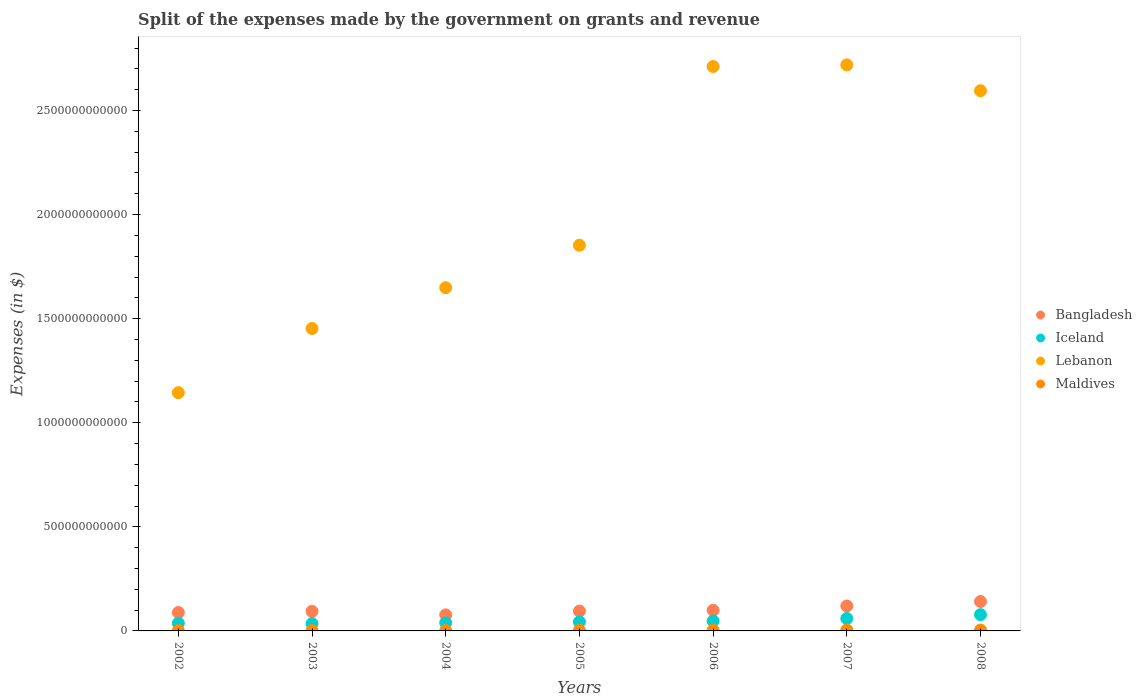How many different coloured dotlines are there?
Offer a very short reply. 4. What is the expenses made by the government on grants and revenue in Maldives in 2003?
Your answer should be compact. 1.79e+09. Across all years, what is the maximum expenses made by the government on grants and revenue in Bangladesh?
Give a very brief answer. 1.41e+11. Across all years, what is the minimum expenses made by the government on grants and revenue in Iceland?
Provide a succinct answer. 3.50e+1. In which year was the expenses made by the government on grants and revenue in Bangladesh maximum?
Provide a succinct answer. 2008. What is the total expenses made by the government on grants and revenue in Bangladesh in the graph?
Your response must be concise. 7.15e+11. What is the difference between the expenses made by the government on grants and revenue in Lebanon in 2003 and that in 2007?
Keep it short and to the point. -1.27e+12. What is the difference between the expenses made by the government on grants and revenue in Iceland in 2002 and the expenses made by the government on grants and revenue in Bangladesh in 2003?
Make the answer very short. -5.69e+1. What is the average expenses made by the government on grants and revenue in Iceland per year?
Keep it short and to the point. 4.86e+1. In the year 2008, what is the difference between the expenses made by the government on grants and revenue in Lebanon and expenses made by the government on grants and revenue in Bangladesh?
Your answer should be compact. 2.45e+12. What is the ratio of the expenses made by the government on grants and revenue in Maldives in 2003 to that in 2007?
Ensure brevity in your answer.  0.39. Is the expenses made by the government on grants and revenue in Iceland in 2002 less than that in 2007?
Your answer should be very brief. Yes. Is the difference between the expenses made by the government on grants and revenue in Lebanon in 2005 and 2006 greater than the difference between the expenses made by the government on grants and revenue in Bangladesh in 2005 and 2006?
Offer a terse response. No. What is the difference between the highest and the second highest expenses made by the government on grants and revenue in Lebanon?
Make the answer very short. 8.00e+09. What is the difference between the highest and the lowest expenses made by the government on grants and revenue in Bangladesh?
Your response must be concise. 6.40e+1. Is it the case that in every year, the sum of the expenses made by the government on grants and revenue in Bangladesh and expenses made by the government on grants and revenue in Iceland  is greater than the sum of expenses made by the government on grants and revenue in Maldives and expenses made by the government on grants and revenue in Lebanon?
Provide a short and direct response. No. Is it the case that in every year, the sum of the expenses made by the government on grants and revenue in Lebanon and expenses made by the government on grants and revenue in Bangladesh  is greater than the expenses made by the government on grants and revenue in Maldives?
Your response must be concise. Yes. Does the expenses made by the government on grants and revenue in Lebanon monotonically increase over the years?
Offer a very short reply. No. Is the expenses made by the government on grants and revenue in Bangladesh strictly greater than the expenses made by the government on grants and revenue in Iceland over the years?
Provide a short and direct response. Yes. How many dotlines are there?
Give a very brief answer. 4. How many years are there in the graph?
Make the answer very short. 7. What is the difference between two consecutive major ticks on the Y-axis?
Provide a short and direct response. 5.00e+11. Are the values on the major ticks of Y-axis written in scientific E-notation?
Keep it short and to the point. No. Does the graph contain any zero values?
Offer a terse response. No. How many legend labels are there?
Your response must be concise. 4. What is the title of the graph?
Ensure brevity in your answer.  Split of the expenses made by the government on grants and revenue. Does "Paraguay" appear as one of the legend labels in the graph?
Your response must be concise. No. What is the label or title of the Y-axis?
Provide a succinct answer. Expenses (in $). What is the Expenses (in $) in Bangladesh in 2002?
Provide a succinct answer. 8.84e+1. What is the Expenses (in $) of Iceland in 2002?
Provide a succinct answer. 3.72e+1. What is the Expenses (in $) in Lebanon in 2002?
Ensure brevity in your answer.  1.14e+12. What is the Expenses (in $) of Maldives in 2002?
Your answer should be very brief. 1.62e+09. What is the Expenses (in $) in Bangladesh in 2003?
Provide a short and direct response. 9.41e+1. What is the Expenses (in $) of Iceland in 2003?
Provide a succinct answer. 3.50e+1. What is the Expenses (in $) of Lebanon in 2003?
Ensure brevity in your answer.  1.45e+12. What is the Expenses (in $) of Maldives in 2003?
Ensure brevity in your answer.  1.79e+09. What is the Expenses (in $) in Bangladesh in 2004?
Give a very brief answer. 7.72e+1. What is the Expenses (in $) in Iceland in 2004?
Keep it short and to the point. 3.89e+1. What is the Expenses (in $) in Lebanon in 2004?
Provide a succinct answer. 1.65e+12. What is the Expenses (in $) of Maldives in 2004?
Give a very brief answer. 1.76e+09. What is the Expenses (in $) in Bangladesh in 2005?
Provide a short and direct response. 9.52e+1. What is the Expenses (in $) of Iceland in 2005?
Provide a succinct answer. 4.34e+1. What is the Expenses (in $) of Lebanon in 2005?
Offer a very short reply. 1.85e+12. What is the Expenses (in $) in Maldives in 2005?
Ensure brevity in your answer.  2.86e+09. What is the Expenses (in $) of Bangladesh in 2006?
Offer a terse response. 9.91e+1. What is the Expenses (in $) of Iceland in 2006?
Offer a very short reply. 4.77e+1. What is the Expenses (in $) in Lebanon in 2006?
Your answer should be compact. 2.71e+12. What is the Expenses (in $) of Maldives in 2006?
Offer a very short reply. 3.73e+09. What is the Expenses (in $) of Bangladesh in 2007?
Offer a terse response. 1.20e+11. What is the Expenses (in $) in Iceland in 2007?
Offer a terse response. 5.97e+1. What is the Expenses (in $) of Lebanon in 2007?
Your response must be concise. 2.72e+12. What is the Expenses (in $) of Maldives in 2007?
Your answer should be very brief. 4.63e+09. What is the Expenses (in $) in Bangladesh in 2008?
Ensure brevity in your answer.  1.41e+11. What is the Expenses (in $) of Iceland in 2008?
Offer a very short reply. 7.80e+1. What is the Expenses (in $) of Lebanon in 2008?
Keep it short and to the point. 2.59e+12. What is the Expenses (in $) in Maldives in 2008?
Keep it short and to the point. 4.05e+09. Across all years, what is the maximum Expenses (in $) of Bangladesh?
Ensure brevity in your answer.  1.41e+11. Across all years, what is the maximum Expenses (in $) in Iceland?
Offer a terse response. 7.80e+1. Across all years, what is the maximum Expenses (in $) in Lebanon?
Your answer should be compact. 2.72e+12. Across all years, what is the maximum Expenses (in $) of Maldives?
Provide a short and direct response. 4.63e+09. Across all years, what is the minimum Expenses (in $) in Bangladesh?
Offer a very short reply. 7.72e+1. Across all years, what is the minimum Expenses (in $) in Iceland?
Your answer should be very brief. 3.50e+1. Across all years, what is the minimum Expenses (in $) of Lebanon?
Provide a short and direct response. 1.14e+12. Across all years, what is the minimum Expenses (in $) in Maldives?
Your answer should be very brief. 1.62e+09. What is the total Expenses (in $) in Bangladesh in the graph?
Offer a terse response. 7.15e+11. What is the total Expenses (in $) in Iceland in the graph?
Your answer should be compact. 3.40e+11. What is the total Expenses (in $) in Lebanon in the graph?
Your answer should be compact. 1.41e+13. What is the total Expenses (in $) in Maldives in the graph?
Ensure brevity in your answer.  2.04e+1. What is the difference between the Expenses (in $) of Bangladesh in 2002 and that in 2003?
Your response must be concise. -5.69e+09. What is the difference between the Expenses (in $) in Iceland in 2002 and that in 2003?
Offer a very short reply. 2.13e+09. What is the difference between the Expenses (in $) of Lebanon in 2002 and that in 2003?
Offer a very short reply. -3.08e+11. What is the difference between the Expenses (in $) in Maldives in 2002 and that in 2003?
Ensure brevity in your answer.  -1.73e+08. What is the difference between the Expenses (in $) in Bangladesh in 2002 and that in 2004?
Offer a very short reply. 1.12e+1. What is the difference between the Expenses (in $) in Iceland in 2002 and that in 2004?
Provide a succinct answer. -1.70e+09. What is the difference between the Expenses (in $) of Lebanon in 2002 and that in 2004?
Make the answer very short. -5.04e+11. What is the difference between the Expenses (in $) in Maldives in 2002 and that in 2004?
Keep it short and to the point. -1.38e+08. What is the difference between the Expenses (in $) of Bangladesh in 2002 and that in 2005?
Offer a very short reply. -6.87e+09. What is the difference between the Expenses (in $) of Iceland in 2002 and that in 2005?
Your answer should be compact. -6.27e+09. What is the difference between the Expenses (in $) of Lebanon in 2002 and that in 2005?
Your answer should be very brief. -7.08e+11. What is the difference between the Expenses (in $) in Maldives in 2002 and that in 2005?
Ensure brevity in your answer.  -1.24e+09. What is the difference between the Expenses (in $) in Bangladesh in 2002 and that in 2006?
Your answer should be compact. -1.07e+1. What is the difference between the Expenses (in $) in Iceland in 2002 and that in 2006?
Keep it short and to the point. -1.06e+1. What is the difference between the Expenses (in $) in Lebanon in 2002 and that in 2006?
Provide a short and direct response. -1.57e+12. What is the difference between the Expenses (in $) in Maldives in 2002 and that in 2006?
Offer a terse response. -2.12e+09. What is the difference between the Expenses (in $) of Bangladesh in 2002 and that in 2007?
Ensure brevity in your answer.  -3.15e+1. What is the difference between the Expenses (in $) in Iceland in 2002 and that in 2007?
Your response must be concise. -2.25e+1. What is the difference between the Expenses (in $) of Lebanon in 2002 and that in 2007?
Give a very brief answer. -1.57e+12. What is the difference between the Expenses (in $) in Maldives in 2002 and that in 2007?
Keep it short and to the point. -3.01e+09. What is the difference between the Expenses (in $) in Bangladesh in 2002 and that in 2008?
Your answer should be compact. -5.28e+1. What is the difference between the Expenses (in $) of Iceland in 2002 and that in 2008?
Give a very brief answer. -4.09e+1. What is the difference between the Expenses (in $) in Lebanon in 2002 and that in 2008?
Your answer should be very brief. -1.45e+12. What is the difference between the Expenses (in $) in Maldives in 2002 and that in 2008?
Make the answer very short. -2.43e+09. What is the difference between the Expenses (in $) in Bangladesh in 2003 and that in 2004?
Your answer should be compact. 1.69e+1. What is the difference between the Expenses (in $) in Iceland in 2003 and that in 2004?
Give a very brief answer. -3.83e+09. What is the difference between the Expenses (in $) of Lebanon in 2003 and that in 2004?
Offer a very short reply. -1.96e+11. What is the difference between the Expenses (in $) in Maldives in 2003 and that in 2004?
Ensure brevity in your answer.  3.49e+07. What is the difference between the Expenses (in $) in Bangladesh in 2003 and that in 2005?
Your response must be concise. -1.18e+09. What is the difference between the Expenses (in $) of Iceland in 2003 and that in 2005?
Offer a very short reply. -8.40e+09. What is the difference between the Expenses (in $) of Lebanon in 2003 and that in 2005?
Provide a short and direct response. -4.00e+11. What is the difference between the Expenses (in $) of Maldives in 2003 and that in 2005?
Your answer should be very brief. -1.06e+09. What is the difference between the Expenses (in $) in Bangladesh in 2003 and that in 2006?
Your answer should be very brief. -4.99e+09. What is the difference between the Expenses (in $) of Iceland in 2003 and that in 2006?
Keep it short and to the point. -1.27e+1. What is the difference between the Expenses (in $) in Lebanon in 2003 and that in 2006?
Your answer should be compact. -1.26e+12. What is the difference between the Expenses (in $) in Maldives in 2003 and that in 2006?
Your response must be concise. -1.94e+09. What is the difference between the Expenses (in $) of Bangladesh in 2003 and that in 2007?
Offer a terse response. -2.58e+1. What is the difference between the Expenses (in $) of Iceland in 2003 and that in 2007?
Provide a succinct answer. -2.47e+1. What is the difference between the Expenses (in $) of Lebanon in 2003 and that in 2007?
Your answer should be very brief. -1.27e+12. What is the difference between the Expenses (in $) in Maldives in 2003 and that in 2007?
Your answer should be compact. -2.84e+09. What is the difference between the Expenses (in $) in Bangladesh in 2003 and that in 2008?
Ensure brevity in your answer.  -4.71e+1. What is the difference between the Expenses (in $) in Iceland in 2003 and that in 2008?
Provide a succinct answer. -4.30e+1. What is the difference between the Expenses (in $) in Lebanon in 2003 and that in 2008?
Give a very brief answer. -1.14e+12. What is the difference between the Expenses (in $) in Maldives in 2003 and that in 2008?
Provide a short and direct response. -2.26e+09. What is the difference between the Expenses (in $) of Bangladesh in 2004 and that in 2005?
Offer a terse response. -1.80e+1. What is the difference between the Expenses (in $) of Iceland in 2004 and that in 2005?
Provide a succinct answer. -4.57e+09. What is the difference between the Expenses (in $) in Lebanon in 2004 and that in 2005?
Offer a very short reply. -2.04e+11. What is the difference between the Expenses (in $) of Maldives in 2004 and that in 2005?
Make the answer very short. -1.10e+09. What is the difference between the Expenses (in $) in Bangladesh in 2004 and that in 2006?
Keep it short and to the point. -2.18e+1. What is the difference between the Expenses (in $) of Iceland in 2004 and that in 2006?
Keep it short and to the point. -8.86e+09. What is the difference between the Expenses (in $) of Lebanon in 2004 and that in 2006?
Offer a terse response. -1.06e+12. What is the difference between the Expenses (in $) of Maldives in 2004 and that in 2006?
Provide a succinct answer. -1.98e+09. What is the difference between the Expenses (in $) in Bangladesh in 2004 and that in 2007?
Provide a succinct answer. -4.27e+1. What is the difference between the Expenses (in $) in Iceland in 2004 and that in 2007?
Make the answer very short. -2.08e+1. What is the difference between the Expenses (in $) of Lebanon in 2004 and that in 2007?
Your response must be concise. -1.07e+12. What is the difference between the Expenses (in $) in Maldives in 2004 and that in 2007?
Give a very brief answer. -2.87e+09. What is the difference between the Expenses (in $) in Bangladesh in 2004 and that in 2008?
Give a very brief answer. -6.40e+1. What is the difference between the Expenses (in $) of Iceland in 2004 and that in 2008?
Provide a succinct answer. -3.92e+1. What is the difference between the Expenses (in $) in Lebanon in 2004 and that in 2008?
Keep it short and to the point. -9.46e+11. What is the difference between the Expenses (in $) in Maldives in 2004 and that in 2008?
Ensure brevity in your answer.  -2.29e+09. What is the difference between the Expenses (in $) in Bangladesh in 2005 and that in 2006?
Make the answer very short. -3.81e+09. What is the difference between the Expenses (in $) of Iceland in 2005 and that in 2006?
Offer a very short reply. -4.29e+09. What is the difference between the Expenses (in $) of Lebanon in 2005 and that in 2006?
Offer a very short reply. -8.58e+11. What is the difference between the Expenses (in $) in Maldives in 2005 and that in 2006?
Provide a succinct answer. -8.79e+08. What is the difference between the Expenses (in $) in Bangladesh in 2005 and that in 2007?
Give a very brief answer. -2.46e+1. What is the difference between the Expenses (in $) of Iceland in 2005 and that in 2007?
Ensure brevity in your answer.  -1.63e+1. What is the difference between the Expenses (in $) of Lebanon in 2005 and that in 2007?
Your answer should be very brief. -8.66e+11. What is the difference between the Expenses (in $) in Maldives in 2005 and that in 2007?
Offer a terse response. -1.77e+09. What is the difference between the Expenses (in $) of Bangladesh in 2005 and that in 2008?
Keep it short and to the point. -4.59e+1. What is the difference between the Expenses (in $) in Iceland in 2005 and that in 2008?
Your answer should be compact. -3.46e+1. What is the difference between the Expenses (in $) of Lebanon in 2005 and that in 2008?
Offer a very short reply. -7.42e+11. What is the difference between the Expenses (in $) in Maldives in 2005 and that in 2008?
Make the answer very short. -1.19e+09. What is the difference between the Expenses (in $) of Bangladesh in 2006 and that in 2007?
Offer a very short reply. -2.08e+1. What is the difference between the Expenses (in $) of Iceland in 2006 and that in 2007?
Provide a succinct answer. -1.20e+1. What is the difference between the Expenses (in $) in Lebanon in 2006 and that in 2007?
Provide a succinct answer. -8.00e+09. What is the difference between the Expenses (in $) of Maldives in 2006 and that in 2007?
Ensure brevity in your answer.  -8.95e+08. What is the difference between the Expenses (in $) of Bangladesh in 2006 and that in 2008?
Keep it short and to the point. -4.21e+1. What is the difference between the Expenses (in $) in Iceland in 2006 and that in 2008?
Make the answer very short. -3.03e+1. What is the difference between the Expenses (in $) of Lebanon in 2006 and that in 2008?
Your answer should be very brief. 1.16e+11. What is the difference between the Expenses (in $) of Maldives in 2006 and that in 2008?
Provide a short and direct response. -3.13e+08. What is the difference between the Expenses (in $) in Bangladesh in 2007 and that in 2008?
Give a very brief answer. -2.13e+1. What is the difference between the Expenses (in $) in Iceland in 2007 and that in 2008?
Offer a terse response. -1.83e+1. What is the difference between the Expenses (in $) in Lebanon in 2007 and that in 2008?
Make the answer very short. 1.24e+11. What is the difference between the Expenses (in $) in Maldives in 2007 and that in 2008?
Your response must be concise. 5.82e+08. What is the difference between the Expenses (in $) of Bangladesh in 2002 and the Expenses (in $) of Iceland in 2003?
Make the answer very short. 5.33e+1. What is the difference between the Expenses (in $) of Bangladesh in 2002 and the Expenses (in $) of Lebanon in 2003?
Offer a terse response. -1.36e+12. What is the difference between the Expenses (in $) of Bangladesh in 2002 and the Expenses (in $) of Maldives in 2003?
Ensure brevity in your answer.  8.66e+1. What is the difference between the Expenses (in $) in Iceland in 2002 and the Expenses (in $) in Lebanon in 2003?
Provide a succinct answer. -1.42e+12. What is the difference between the Expenses (in $) of Iceland in 2002 and the Expenses (in $) of Maldives in 2003?
Keep it short and to the point. 3.54e+1. What is the difference between the Expenses (in $) of Lebanon in 2002 and the Expenses (in $) of Maldives in 2003?
Your answer should be compact. 1.14e+12. What is the difference between the Expenses (in $) in Bangladesh in 2002 and the Expenses (in $) in Iceland in 2004?
Offer a terse response. 4.95e+1. What is the difference between the Expenses (in $) in Bangladesh in 2002 and the Expenses (in $) in Lebanon in 2004?
Your answer should be very brief. -1.56e+12. What is the difference between the Expenses (in $) of Bangladesh in 2002 and the Expenses (in $) of Maldives in 2004?
Give a very brief answer. 8.66e+1. What is the difference between the Expenses (in $) of Iceland in 2002 and the Expenses (in $) of Lebanon in 2004?
Give a very brief answer. -1.61e+12. What is the difference between the Expenses (in $) of Iceland in 2002 and the Expenses (in $) of Maldives in 2004?
Offer a terse response. 3.54e+1. What is the difference between the Expenses (in $) of Lebanon in 2002 and the Expenses (in $) of Maldives in 2004?
Your answer should be very brief. 1.14e+12. What is the difference between the Expenses (in $) in Bangladesh in 2002 and the Expenses (in $) in Iceland in 2005?
Your answer should be compact. 4.49e+1. What is the difference between the Expenses (in $) of Bangladesh in 2002 and the Expenses (in $) of Lebanon in 2005?
Keep it short and to the point. -1.76e+12. What is the difference between the Expenses (in $) in Bangladesh in 2002 and the Expenses (in $) in Maldives in 2005?
Offer a terse response. 8.55e+1. What is the difference between the Expenses (in $) in Iceland in 2002 and the Expenses (in $) in Lebanon in 2005?
Give a very brief answer. -1.82e+12. What is the difference between the Expenses (in $) in Iceland in 2002 and the Expenses (in $) in Maldives in 2005?
Provide a short and direct response. 3.43e+1. What is the difference between the Expenses (in $) of Lebanon in 2002 and the Expenses (in $) of Maldives in 2005?
Your answer should be compact. 1.14e+12. What is the difference between the Expenses (in $) in Bangladesh in 2002 and the Expenses (in $) in Iceland in 2006?
Provide a succinct answer. 4.07e+1. What is the difference between the Expenses (in $) in Bangladesh in 2002 and the Expenses (in $) in Lebanon in 2006?
Your answer should be compact. -2.62e+12. What is the difference between the Expenses (in $) in Bangladesh in 2002 and the Expenses (in $) in Maldives in 2006?
Provide a succinct answer. 8.46e+1. What is the difference between the Expenses (in $) in Iceland in 2002 and the Expenses (in $) in Lebanon in 2006?
Make the answer very short. -2.67e+12. What is the difference between the Expenses (in $) of Iceland in 2002 and the Expenses (in $) of Maldives in 2006?
Make the answer very short. 3.34e+1. What is the difference between the Expenses (in $) of Lebanon in 2002 and the Expenses (in $) of Maldives in 2006?
Provide a short and direct response. 1.14e+12. What is the difference between the Expenses (in $) in Bangladesh in 2002 and the Expenses (in $) in Iceland in 2007?
Provide a short and direct response. 2.87e+1. What is the difference between the Expenses (in $) in Bangladesh in 2002 and the Expenses (in $) in Lebanon in 2007?
Ensure brevity in your answer.  -2.63e+12. What is the difference between the Expenses (in $) in Bangladesh in 2002 and the Expenses (in $) in Maldives in 2007?
Your response must be concise. 8.37e+1. What is the difference between the Expenses (in $) in Iceland in 2002 and the Expenses (in $) in Lebanon in 2007?
Ensure brevity in your answer.  -2.68e+12. What is the difference between the Expenses (in $) in Iceland in 2002 and the Expenses (in $) in Maldives in 2007?
Keep it short and to the point. 3.25e+1. What is the difference between the Expenses (in $) in Lebanon in 2002 and the Expenses (in $) in Maldives in 2007?
Offer a very short reply. 1.14e+12. What is the difference between the Expenses (in $) of Bangladesh in 2002 and the Expenses (in $) of Iceland in 2008?
Your response must be concise. 1.03e+1. What is the difference between the Expenses (in $) of Bangladesh in 2002 and the Expenses (in $) of Lebanon in 2008?
Your answer should be very brief. -2.51e+12. What is the difference between the Expenses (in $) of Bangladesh in 2002 and the Expenses (in $) of Maldives in 2008?
Your response must be concise. 8.43e+1. What is the difference between the Expenses (in $) in Iceland in 2002 and the Expenses (in $) in Lebanon in 2008?
Your answer should be compact. -2.56e+12. What is the difference between the Expenses (in $) in Iceland in 2002 and the Expenses (in $) in Maldives in 2008?
Your answer should be very brief. 3.31e+1. What is the difference between the Expenses (in $) of Lebanon in 2002 and the Expenses (in $) of Maldives in 2008?
Ensure brevity in your answer.  1.14e+12. What is the difference between the Expenses (in $) of Bangladesh in 2003 and the Expenses (in $) of Iceland in 2004?
Keep it short and to the point. 5.52e+1. What is the difference between the Expenses (in $) in Bangladesh in 2003 and the Expenses (in $) in Lebanon in 2004?
Your response must be concise. -1.55e+12. What is the difference between the Expenses (in $) in Bangladesh in 2003 and the Expenses (in $) in Maldives in 2004?
Your answer should be very brief. 9.23e+1. What is the difference between the Expenses (in $) of Iceland in 2003 and the Expenses (in $) of Lebanon in 2004?
Offer a very short reply. -1.61e+12. What is the difference between the Expenses (in $) in Iceland in 2003 and the Expenses (in $) in Maldives in 2004?
Your response must be concise. 3.33e+1. What is the difference between the Expenses (in $) of Lebanon in 2003 and the Expenses (in $) of Maldives in 2004?
Offer a terse response. 1.45e+12. What is the difference between the Expenses (in $) in Bangladesh in 2003 and the Expenses (in $) in Iceland in 2005?
Offer a terse response. 5.06e+1. What is the difference between the Expenses (in $) of Bangladesh in 2003 and the Expenses (in $) of Lebanon in 2005?
Your response must be concise. -1.76e+12. What is the difference between the Expenses (in $) of Bangladesh in 2003 and the Expenses (in $) of Maldives in 2005?
Make the answer very short. 9.12e+1. What is the difference between the Expenses (in $) in Iceland in 2003 and the Expenses (in $) in Lebanon in 2005?
Ensure brevity in your answer.  -1.82e+12. What is the difference between the Expenses (in $) in Iceland in 2003 and the Expenses (in $) in Maldives in 2005?
Give a very brief answer. 3.22e+1. What is the difference between the Expenses (in $) in Lebanon in 2003 and the Expenses (in $) in Maldives in 2005?
Ensure brevity in your answer.  1.45e+12. What is the difference between the Expenses (in $) of Bangladesh in 2003 and the Expenses (in $) of Iceland in 2006?
Your response must be concise. 4.63e+1. What is the difference between the Expenses (in $) of Bangladesh in 2003 and the Expenses (in $) of Lebanon in 2006?
Provide a succinct answer. -2.62e+12. What is the difference between the Expenses (in $) in Bangladesh in 2003 and the Expenses (in $) in Maldives in 2006?
Provide a short and direct response. 9.03e+1. What is the difference between the Expenses (in $) of Iceland in 2003 and the Expenses (in $) of Lebanon in 2006?
Offer a very short reply. -2.68e+12. What is the difference between the Expenses (in $) in Iceland in 2003 and the Expenses (in $) in Maldives in 2006?
Give a very brief answer. 3.13e+1. What is the difference between the Expenses (in $) of Lebanon in 2003 and the Expenses (in $) of Maldives in 2006?
Your answer should be compact. 1.45e+12. What is the difference between the Expenses (in $) of Bangladesh in 2003 and the Expenses (in $) of Iceland in 2007?
Provide a short and direct response. 3.44e+1. What is the difference between the Expenses (in $) in Bangladesh in 2003 and the Expenses (in $) in Lebanon in 2007?
Offer a terse response. -2.63e+12. What is the difference between the Expenses (in $) of Bangladesh in 2003 and the Expenses (in $) of Maldives in 2007?
Make the answer very short. 8.94e+1. What is the difference between the Expenses (in $) in Iceland in 2003 and the Expenses (in $) in Lebanon in 2007?
Offer a terse response. -2.68e+12. What is the difference between the Expenses (in $) of Iceland in 2003 and the Expenses (in $) of Maldives in 2007?
Your response must be concise. 3.04e+1. What is the difference between the Expenses (in $) in Lebanon in 2003 and the Expenses (in $) in Maldives in 2007?
Your response must be concise. 1.45e+12. What is the difference between the Expenses (in $) in Bangladesh in 2003 and the Expenses (in $) in Iceland in 2008?
Your answer should be compact. 1.60e+1. What is the difference between the Expenses (in $) of Bangladesh in 2003 and the Expenses (in $) of Lebanon in 2008?
Keep it short and to the point. -2.50e+12. What is the difference between the Expenses (in $) in Bangladesh in 2003 and the Expenses (in $) in Maldives in 2008?
Provide a succinct answer. 9.00e+1. What is the difference between the Expenses (in $) of Iceland in 2003 and the Expenses (in $) of Lebanon in 2008?
Your answer should be very brief. -2.56e+12. What is the difference between the Expenses (in $) in Iceland in 2003 and the Expenses (in $) in Maldives in 2008?
Offer a terse response. 3.10e+1. What is the difference between the Expenses (in $) of Lebanon in 2003 and the Expenses (in $) of Maldives in 2008?
Keep it short and to the point. 1.45e+12. What is the difference between the Expenses (in $) in Bangladesh in 2004 and the Expenses (in $) in Iceland in 2005?
Offer a very short reply. 3.38e+1. What is the difference between the Expenses (in $) in Bangladesh in 2004 and the Expenses (in $) in Lebanon in 2005?
Your response must be concise. -1.78e+12. What is the difference between the Expenses (in $) of Bangladesh in 2004 and the Expenses (in $) of Maldives in 2005?
Your response must be concise. 7.44e+1. What is the difference between the Expenses (in $) of Iceland in 2004 and the Expenses (in $) of Lebanon in 2005?
Keep it short and to the point. -1.81e+12. What is the difference between the Expenses (in $) of Iceland in 2004 and the Expenses (in $) of Maldives in 2005?
Offer a terse response. 3.60e+1. What is the difference between the Expenses (in $) of Lebanon in 2004 and the Expenses (in $) of Maldives in 2005?
Keep it short and to the point. 1.65e+12. What is the difference between the Expenses (in $) of Bangladesh in 2004 and the Expenses (in $) of Iceland in 2006?
Your answer should be very brief. 2.95e+1. What is the difference between the Expenses (in $) of Bangladesh in 2004 and the Expenses (in $) of Lebanon in 2006?
Keep it short and to the point. -2.63e+12. What is the difference between the Expenses (in $) in Bangladesh in 2004 and the Expenses (in $) in Maldives in 2006?
Provide a succinct answer. 7.35e+1. What is the difference between the Expenses (in $) of Iceland in 2004 and the Expenses (in $) of Lebanon in 2006?
Provide a short and direct response. -2.67e+12. What is the difference between the Expenses (in $) in Iceland in 2004 and the Expenses (in $) in Maldives in 2006?
Ensure brevity in your answer.  3.51e+1. What is the difference between the Expenses (in $) of Lebanon in 2004 and the Expenses (in $) of Maldives in 2006?
Keep it short and to the point. 1.64e+12. What is the difference between the Expenses (in $) of Bangladesh in 2004 and the Expenses (in $) of Iceland in 2007?
Your response must be concise. 1.75e+1. What is the difference between the Expenses (in $) of Bangladesh in 2004 and the Expenses (in $) of Lebanon in 2007?
Your answer should be compact. -2.64e+12. What is the difference between the Expenses (in $) of Bangladesh in 2004 and the Expenses (in $) of Maldives in 2007?
Make the answer very short. 7.26e+1. What is the difference between the Expenses (in $) of Iceland in 2004 and the Expenses (in $) of Lebanon in 2007?
Your answer should be compact. -2.68e+12. What is the difference between the Expenses (in $) of Iceland in 2004 and the Expenses (in $) of Maldives in 2007?
Ensure brevity in your answer.  3.42e+1. What is the difference between the Expenses (in $) of Lebanon in 2004 and the Expenses (in $) of Maldives in 2007?
Make the answer very short. 1.64e+12. What is the difference between the Expenses (in $) in Bangladesh in 2004 and the Expenses (in $) in Iceland in 2008?
Your answer should be very brief. -8.20e+08. What is the difference between the Expenses (in $) in Bangladesh in 2004 and the Expenses (in $) in Lebanon in 2008?
Your answer should be compact. -2.52e+12. What is the difference between the Expenses (in $) of Bangladesh in 2004 and the Expenses (in $) of Maldives in 2008?
Provide a succinct answer. 7.32e+1. What is the difference between the Expenses (in $) in Iceland in 2004 and the Expenses (in $) in Lebanon in 2008?
Your answer should be compact. -2.56e+12. What is the difference between the Expenses (in $) in Iceland in 2004 and the Expenses (in $) in Maldives in 2008?
Make the answer very short. 3.48e+1. What is the difference between the Expenses (in $) in Lebanon in 2004 and the Expenses (in $) in Maldives in 2008?
Your answer should be compact. 1.64e+12. What is the difference between the Expenses (in $) in Bangladesh in 2005 and the Expenses (in $) in Iceland in 2006?
Provide a short and direct response. 4.75e+1. What is the difference between the Expenses (in $) of Bangladesh in 2005 and the Expenses (in $) of Lebanon in 2006?
Provide a short and direct response. -2.62e+12. What is the difference between the Expenses (in $) of Bangladesh in 2005 and the Expenses (in $) of Maldives in 2006?
Give a very brief answer. 9.15e+1. What is the difference between the Expenses (in $) in Iceland in 2005 and the Expenses (in $) in Lebanon in 2006?
Offer a terse response. -2.67e+12. What is the difference between the Expenses (in $) of Iceland in 2005 and the Expenses (in $) of Maldives in 2006?
Give a very brief answer. 3.97e+1. What is the difference between the Expenses (in $) of Lebanon in 2005 and the Expenses (in $) of Maldives in 2006?
Make the answer very short. 1.85e+12. What is the difference between the Expenses (in $) in Bangladesh in 2005 and the Expenses (in $) in Iceland in 2007?
Keep it short and to the point. 3.56e+1. What is the difference between the Expenses (in $) of Bangladesh in 2005 and the Expenses (in $) of Lebanon in 2007?
Your response must be concise. -2.62e+12. What is the difference between the Expenses (in $) in Bangladesh in 2005 and the Expenses (in $) in Maldives in 2007?
Make the answer very short. 9.06e+1. What is the difference between the Expenses (in $) in Iceland in 2005 and the Expenses (in $) in Lebanon in 2007?
Give a very brief answer. -2.68e+12. What is the difference between the Expenses (in $) in Iceland in 2005 and the Expenses (in $) in Maldives in 2007?
Keep it short and to the point. 3.88e+1. What is the difference between the Expenses (in $) of Lebanon in 2005 and the Expenses (in $) of Maldives in 2007?
Keep it short and to the point. 1.85e+12. What is the difference between the Expenses (in $) in Bangladesh in 2005 and the Expenses (in $) in Iceland in 2008?
Give a very brief answer. 1.72e+1. What is the difference between the Expenses (in $) of Bangladesh in 2005 and the Expenses (in $) of Lebanon in 2008?
Give a very brief answer. -2.50e+12. What is the difference between the Expenses (in $) in Bangladesh in 2005 and the Expenses (in $) in Maldives in 2008?
Your response must be concise. 9.12e+1. What is the difference between the Expenses (in $) of Iceland in 2005 and the Expenses (in $) of Lebanon in 2008?
Provide a short and direct response. -2.55e+12. What is the difference between the Expenses (in $) in Iceland in 2005 and the Expenses (in $) in Maldives in 2008?
Keep it short and to the point. 3.94e+1. What is the difference between the Expenses (in $) of Lebanon in 2005 and the Expenses (in $) of Maldives in 2008?
Give a very brief answer. 1.85e+12. What is the difference between the Expenses (in $) in Bangladesh in 2006 and the Expenses (in $) in Iceland in 2007?
Keep it short and to the point. 3.94e+1. What is the difference between the Expenses (in $) in Bangladesh in 2006 and the Expenses (in $) in Lebanon in 2007?
Give a very brief answer. -2.62e+12. What is the difference between the Expenses (in $) in Bangladesh in 2006 and the Expenses (in $) in Maldives in 2007?
Offer a terse response. 9.44e+1. What is the difference between the Expenses (in $) of Iceland in 2006 and the Expenses (in $) of Lebanon in 2007?
Make the answer very short. -2.67e+12. What is the difference between the Expenses (in $) in Iceland in 2006 and the Expenses (in $) in Maldives in 2007?
Give a very brief answer. 4.31e+1. What is the difference between the Expenses (in $) of Lebanon in 2006 and the Expenses (in $) of Maldives in 2007?
Your response must be concise. 2.71e+12. What is the difference between the Expenses (in $) in Bangladesh in 2006 and the Expenses (in $) in Iceland in 2008?
Provide a succinct answer. 2.10e+1. What is the difference between the Expenses (in $) in Bangladesh in 2006 and the Expenses (in $) in Lebanon in 2008?
Offer a terse response. -2.50e+12. What is the difference between the Expenses (in $) of Bangladesh in 2006 and the Expenses (in $) of Maldives in 2008?
Offer a terse response. 9.50e+1. What is the difference between the Expenses (in $) of Iceland in 2006 and the Expenses (in $) of Lebanon in 2008?
Offer a very short reply. -2.55e+12. What is the difference between the Expenses (in $) in Iceland in 2006 and the Expenses (in $) in Maldives in 2008?
Make the answer very short. 4.37e+1. What is the difference between the Expenses (in $) of Lebanon in 2006 and the Expenses (in $) of Maldives in 2008?
Keep it short and to the point. 2.71e+12. What is the difference between the Expenses (in $) of Bangladesh in 2007 and the Expenses (in $) of Iceland in 2008?
Your answer should be compact. 4.19e+1. What is the difference between the Expenses (in $) in Bangladesh in 2007 and the Expenses (in $) in Lebanon in 2008?
Give a very brief answer. -2.48e+12. What is the difference between the Expenses (in $) of Bangladesh in 2007 and the Expenses (in $) of Maldives in 2008?
Offer a very short reply. 1.16e+11. What is the difference between the Expenses (in $) in Iceland in 2007 and the Expenses (in $) in Lebanon in 2008?
Your response must be concise. -2.54e+12. What is the difference between the Expenses (in $) in Iceland in 2007 and the Expenses (in $) in Maldives in 2008?
Provide a short and direct response. 5.56e+1. What is the difference between the Expenses (in $) in Lebanon in 2007 and the Expenses (in $) in Maldives in 2008?
Keep it short and to the point. 2.72e+12. What is the average Expenses (in $) of Bangladesh per year?
Provide a short and direct response. 1.02e+11. What is the average Expenses (in $) in Iceland per year?
Your answer should be very brief. 4.86e+1. What is the average Expenses (in $) of Lebanon per year?
Offer a terse response. 2.02e+12. What is the average Expenses (in $) of Maldives per year?
Give a very brief answer. 2.92e+09. In the year 2002, what is the difference between the Expenses (in $) in Bangladesh and Expenses (in $) in Iceland?
Ensure brevity in your answer.  5.12e+1. In the year 2002, what is the difference between the Expenses (in $) of Bangladesh and Expenses (in $) of Lebanon?
Give a very brief answer. -1.06e+12. In the year 2002, what is the difference between the Expenses (in $) of Bangladesh and Expenses (in $) of Maldives?
Offer a very short reply. 8.68e+1. In the year 2002, what is the difference between the Expenses (in $) of Iceland and Expenses (in $) of Lebanon?
Ensure brevity in your answer.  -1.11e+12. In the year 2002, what is the difference between the Expenses (in $) of Iceland and Expenses (in $) of Maldives?
Keep it short and to the point. 3.55e+1. In the year 2002, what is the difference between the Expenses (in $) of Lebanon and Expenses (in $) of Maldives?
Ensure brevity in your answer.  1.14e+12. In the year 2003, what is the difference between the Expenses (in $) in Bangladesh and Expenses (in $) in Iceland?
Make the answer very short. 5.90e+1. In the year 2003, what is the difference between the Expenses (in $) of Bangladesh and Expenses (in $) of Lebanon?
Ensure brevity in your answer.  -1.36e+12. In the year 2003, what is the difference between the Expenses (in $) of Bangladesh and Expenses (in $) of Maldives?
Make the answer very short. 9.23e+1. In the year 2003, what is the difference between the Expenses (in $) of Iceland and Expenses (in $) of Lebanon?
Provide a short and direct response. -1.42e+12. In the year 2003, what is the difference between the Expenses (in $) of Iceland and Expenses (in $) of Maldives?
Ensure brevity in your answer.  3.32e+1. In the year 2003, what is the difference between the Expenses (in $) in Lebanon and Expenses (in $) in Maldives?
Provide a short and direct response. 1.45e+12. In the year 2004, what is the difference between the Expenses (in $) in Bangladesh and Expenses (in $) in Iceland?
Offer a terse response. 3.84e+1. In the year 2004, what is the difference between the Expenses (in $) in Bangladesh and Expenses (in $) in Lebanon?
Offer a terse response. -1.57e+12. In the year 2004, what is the difference between the Expenses (in $) of Bangladesh and Expenses (in $) of Maldives?
Keep it short and to the point. 7.55e+1. In the year 2004, what is the difference between the Expenses (in $) of Iceland and Expenses (in $) of Lebanon?
Provide a short and direct response. -1.61e+12. In the year 2004, what is the difference between the Expenses (in $) of Iceland and Expenses (in $) of Maldives?
Provide a succinct answer. 3.71e+1. In the year 2004, what is the difference between the Expenses (in $) of Lebanon and Expenses (in $) of Maldives?
Your answer should be very brief. 1.65e+12. In the year 2005, what is the difference between the Expenses (in $) of Bangladesh and Expenses (in $) of Iceland?
Make the answer very short. 5.18e+1. In the year 2005, what is the difference between the Expenses (in $) in Bangladesh and Expenses (in $) in Lebanon?
Provide a succinct answer. -1.76e+12. In the year 2005, what is the difference between the Expenses (in $) in Bangladesh and Expenses (in $) in Maldives?
Provide a short and direct response. 9.24e+1. In the year 2005, what is the difference between the Expenses (in $) in Iceland and Expenses (in $) in Lebanon?
Offer a very short reply. -1.81e+12. In the year 2005, what is the difference between the Expenses (in $) of Iceland and Expenses (in $) of Maldives?
Your response must be concise. 4.06e+1. In the year 2005, what is the difference between the Expenses (in $) of Lebanon and Expenses (in $) of Maldives?
Give a very brief answer. 1.85e+12. In the year 2006, what is the difference between the Expenses (in $) of Bangladesh and Expenses (in $) of Iceland?
Offer a very short reply. 5.13e+1. In the year 2006, what is the difference between the Expenses (in $) of Bangladesh and Expenses (in $) of Lebanon?
Ensure brevity in your answer.  -2.61e+12. In the year 2006, what is the difference between the Expenses (in $) of Bangladesh and Expenses (in $) of Maldives?
Make the answer very short. 9.53e+1. In the year 2006, what is the difference between the Expenses (in $) of Iceland and Expenses (in $) of Lebanon?
Make the answer very short. -2.66e+12. In the year 2006, what is the difference between the Expenses (in $) in Iceland and Expenses (in $) in Maldives?
Keep it short and to the point. 4.40e+1. In the year 2006, what is the difference between the Expenses (in $) of Lebanon and Expenses (in $) of Maldives?
Make the answer very short. 2.71e+12. In the year 2007, what is the difference between the Expenses (in $) of Bangladesh and Expenses (in $) of Iceland?
Make the answer very short. 6.02e+1. In the year 2007, what is the difference between the Expenses (in $) in Bangladesh and Expenses (in $) in Lebanon?
Provide a short and direct response. -2.60e+12. In the year 2007, what is the difference between the Expenses (in $) of Bangladesh and Expenses (in $) of Maldives?
Your answer should be very brief. 1.15e+11. In the year 2007, what is the difference between the Expenses (in $) of Iceland and Expenses (in $) of Lebanon?
Keep it short and to the point. -2.66e+12. In the year 2007, what is the difference between the Expenses (in $) in Iceland and Expenses (in $) in Maldives?
Offer a terse response. 5.51e+1. In the year 2007, what is the difference between the Expenses (in $) of Lebanon and Expenses (in $) of Maldives?
Provide a short and direct response. 2.71e+12. In the year 2008, what is the difference between the Expenses (in $) in Bangladesh and Expenses (in $) in Iceland?
Offer a very short reply. 6.31e+1. In the year 2008, what is the difference between the Expenses (in $) of Bangladesh and Expenses (in $) of Lebanon?
Keep it short and to the point. -2.45e+12. In the year 2008, what is the difference between the Expenses (in $) in Bangladesh and Expenses (in $) in Maldives?
Your answer should be compact. 1.37e+11. In the year 2008, what is the difference between the Expenses (in $) in Iceland and Expenses (in $) in Lebanon?
Keep it short and to the point. -2.52e+12. In the year 2008, what is the difference between the Expenses (in $) of Iceland and Expenses (in $) of Maldives?
Ensure brevity in your answer.  7.40e+1. In the year 2008, what is the difference between the Expenses (in $) of Lebanon and Expenses (in $) of Maldives?
Your answer should be very brief. 2.59e+12. What is the ratio of the Expenses (in $) in Bangladesh in 2002 to that in 2003?
Provide a short and direct response. 0.94. What is the ratio of the Expenses (in $) of Iceland in 2002 to that in 2003?
Provide a succinct answer. 1.06. What is the ratio of the Expenses (in $) of Lebanon in 2002 to that in 2003?
Keep it short and to the point. 0.79. What is the ratio of the Expenses (in $) of Maldives in 2002 to that in 2003?
Give a very brief answer. 0.9. What is the ratio of the Expenses (in $) in Bangladesh in 2002 to that in 2004?
Give a very brief answer. 1.14. What is the ratio of the Expenses (in $) in Iceland in 2002 to that in 2004?
Provide a succinct answer. 0.96. What is the ratio of the Expenses (in $) in Lebanon in 2002 to that in 2004?
Make the answer very short. 0.69. What is the ratio of the Expenses (in $) of Maldives in 2002 to that in 2004?
Your answer should be compact. 0.92. What is the ratio of the Expenses (in $) of Bangladesh in 2002 to that in 2005?
Ensure brevity in your answer.  0.93. What is the ratio of the Expenses (in $) of Iceland in 2002 to that in 2005?
Keep it short and to the point. 0.86. What is the ratio of the Expenses (in $) in Lebanon in 2002 to that in 2005?
Provide a succinct answer. 0.62. What is the ratio of the Expenses (in $) of Maldives in 2002 to that in 2005?
Keep it short and to the point. 0.57. What is the ratio of the Expenses (in $) in Bangladesh in 2002 to that in 2006?
Provide a succinct answer. 0.89. What is the ratio of the Expenses (in $) in Iceland in 2002 to that in 2006?
Your answer should be compact. 0.78. What is the ratio of the Expenses (in $) in Lebanon in 2002 to that in 2006?
Ensure brevity in your answer.  0.42. What is the ratio of the Expenses (in $) in Maldives in 2002 to that in 2006?
Offer a terse response. 0.43. What is the ratio of the Expenses (in $) in Bangladesh in 2002 to that in 2007?
Give a very brief answer. 0.74. What is the ratio of the Expenses (in $) in Iceland in 2002 to that in 2007?
Offer a terse response. 0.62. What is the ratio of the Expenses (in $) of Lebanon in 2002 to that in 2007?
Your response must be concise. 0.42. What is the ratio of the Expenses (in $) in Maldives in 2002 to that in 2007?
Provide a succinct answer. 0.35. What is the ratio of the Expenses (in $) of Bangladesh in 2002 to that in 2008?
Provide a short and direct response. 0.63. What is the ratio of the Expenses (in $) in Iceland in 2002 to that in 2008?
Make the answer very short. 0.48. What is the ratio of the Expenses (in $) in Lebanon in 2002 to that in 2008?
Your response must be concise. 0.44. What is the ratio of the Expenses (in $) in Maldives in 2002 to that in 2008?
Your answer should be compact. 0.4. What is the ratio of the Expenses (in $) in Bangladesh in 2003 to that in 2004?
Your response must be concise. 1.22. What is the ratio of the Expenses (in $) of Iceland in 2003 to that in 2004?
Your answer should be very brief. 0.9. What is the ratio of the Expenses (in $) in Lebanon in 2003 to that in 2004?
Your response must be concise. 0.88. What is the ratio of the Expenses (in $) of Maldives in 2003 to that in 2004?
Offer a terse response. 1.02. What is the ratio of the Expenses (in $) in Bangladesh in 2003 to that in 2005?
Give a very brief answer. 0.99. What is the ratio of the Expenses (in $) in Iceland in 2003 to that in 2005?
Provide a short and direct response. 0.81. What is the ratio of the Expenses (in $) in Lebanon in 2003 to that in 2005?
Keep it short and to the point. 0.78. What is the ratio of the Expenses (in $) in Maldives in 2003 to that in 2005?
Offer a terse response. 0.63. What is the ratio of the Expenses (in $) in Bangladesh in 2003 to that in 2006?
Offer a terse response. 0.95. What is the ratio of the Expenses (in $) of Iceland in 2003 to that in 2006?
Keep it short and to the point. 0.73. What is the ratio of the Expenses (in $) of Lebanon in 2003 to that in 2006?
Your answer should be compact. 0.54. What is the ratio of the Expenses (in $) of Maldives in 2003 to that in 2006?
Provide a succinct answer. 0.48. What is the ratio of the Expenses (in $) of Bangladesh in 2003 to that in 2007?
Offer a very short reply. 0.78. What is the ratio of the Expenses (in $) in Iceland in 2003 to that in 2007?
Your answer should be very brief. 0.59. What is the ratio of the Expenses (in $) in Lebanon in 2003 to that in 2007?
Make the answer very short. 0.53. What is the ratio of the Expenses (in $) in Maldives in 2003 to that in 2007?
Your answer should be compact. 0.39. What is the ratio of the Expenses (in $) of Bangladesh in 2003 to that in 2008?
Offer a very short reply. 0.67. What is the ratio of the Expenses (in $) of Iceland in 2003 to that in 2008?
Keep it short and to the point. 0.45. What is the ratio of the Expenses (in $) in Lebanon in 2003 to that in 2008?
Offer a terse response. 0.56. What is the ratio of the Expenses (in $) in Maldives in 2003 to that in 2008?
Make the answer very short. 0.44. What is the ratio of the Expenses (in $) in Bangladesh in 2004 to that in 2005?
Ensure brevity in your answer.  0.81. What is the ratio of the Expenses (in $) of Iceland in 2004 to that in 2005?
Your answer should be compact. 0.89. What is the ratio of the Expenses (in $) of Lebanon in 2004 to that in 2005?
Provide a succinct answer. 0.89. What is the ratio of the Expenses (in $) in Maldives in 2004 to that in 2005?
Keep it short and to the point. 0.62. What is the ratio of the Expenses (in $) of Bangladesh in 2004 to that in 2006?
Offer a very short reply. 0.78. What is the ratio of the Expenses (in $) in Iceland in 2004 to that in 2006?
Your answer should be very brief. 0.81. What is the ratio of the Expenses (in $) of Lebanon in 2004 to that in 2006?
Give a very brief answer. 0.61. What is the ratio of the Expenses (in $) in Maldives in 2004 to that in 2006?
Keep it short and to the point. 0.47. What is the ratio of the Expenses (in $) of Bangladesh in 2004 to that in 2007?
Your answer should be compact. 0.64. What is the ratio of the Expenses (in $) in Iceland in 2004 to that in 2007?
Your response must be concise. 0.65. What is the ratio of the Expenses (in $) in Lebanon in 2004 to that in 2007?
Provide a succinct answer. 0.61. What is the ratio of the Expenses (in $) of Maldives in 2004 to that in 2007?
Provide a succinct answer. 0.38. What is the ratio of the Expenses (in $) of Bangladesh in 2004 to that in 2008?
Ensure brevity in your answer.  0.55. What is the ratio of the Expenses (in $) in Iceland in 2004 to that in 2008?
Your answer should be very brief. 0.5. What is the ratio of the Expenses (in $) in Lebanon in 2004 to that in 2008?
Offer a terse response. 0.64. What is the ratio of the Expenses (in $) in Maldives in 2004 to that in 2008?
Give a very brief answer. 0.43. What is the ratio of the Expenses (in $) in Bangladesh in 2005 to that in 2006?
Your answer should be very brief. 0.96. What is the ratio of the Expenses (in $) of Iceland in 2005 to that in 2006?
Give a very brief answer. 0.91. What is the ratio of the Expenses (in $) in Lebanon in 2005 to that in 2006?
Your response must be concise. 0.68. What is the ratio of the Expenses (in $) in Maldives in 2005 to that in 2006?
Your answer should be very brief. 0.76. What is the ratio of the Expenses (in $) of Bangladesh in 2005 to that in 2007?
Keep it short and to the point. 0.79. What is the ratio of the Expenses (in $) of Iceland in 2005 to that in 2007?
Offer a very short reply. 0.73. What is the ratio of the Expenses (in $) in Lebanon in 2005 to that in 2007?
Ensure brevity in your answer.  0.68. What is the ratio of the Expenses (in $) of Maldives in 2005 to that in 2007?
Offer a very short reply. 0.62. What is the ratio of the Expenses (in $) of Bangladesh in 2005 to that in 2008?
Offer a terse response. 0.67. What is the ratio of the Expenses (in $) in Iceland in 2005 to that in 2008?
Your response must be concise. 0.56. What is the ratio of the Expenses (in $) of Lebanon in 2005 to that in 2008?
Make the answer very short. 0.71. What is the ratio of the Expenses (in $) in Maldives in 2005 to that in 2008?
Offer a very short reply. 0.71. What is the ratio of the Expenses (in $) in Bangladesh in 2006 to that in 2007?
Give a very brief answer. 0.83. What is the ratio of the Expenses (in $) in Iceland in 2006 to that in 2007?
Your answer should be compact. 0.8. What is the ratio of the Expenses (in $) of Lebanon in 2006 to that in 2007?
Your answer should be very brief. 1. What is the ratio of the Expenses (in $) of Maldives in 2006 to that in 2007?
Provide a short and direct response. 0.81. What is the ratio of the Expenses (in $) in Bangladesh in 2006 to that in 2008?
Give a very brief answer. 0.7. What is the ratio of the Expenses (in $) in Iceland in 2006 to that in 2008?
Provide a short and direct response. 0.61. What is the ratio of the Expenses (in $) in Lebanon in 2006 to that in 2008?
Provide a short and direct response. 1.04. What is the ratio of the Expenses (in $) in Maldives in 2006 to that in 2008?
Provide a short and direct response. 0.92. What is the ratio of the Expenses (in $) of Bangladesh in 2007 to that in 2008?
Your answer should be compact. 0.85. What is the ratio of the Expenses (in $) of Iceland in 2007 to that in 2008?
Give a very brief answer. 0.76. What is the ratio of the Expenses (in $) of Lebanon in 2007 to that in 2008?
Your answer should be compact. 1.05. What is the ratio of the Expenses (in $) of Maldives in 2007 to that in 2008?
Give a very brief answer. 1.14. What is the difference between the highest and the second highest Expenses (in $) of Bangladesh?
Keep it short and to the point. 2.13e+1. What is the difference between the highest and the second highest Expenses (in $) of Iceland?
Your answer should be compact. 1.83e+1. What is the difference between the highest and the second highest Expenses (in $) of Lebanon?
Your response must be concise. 8.00e+09. What is the difference between the highest and the second highest Expenses (in $) of Maldives?
Offer a very short reply. 5.82e+08. What is the difference between the highest and the lowest Expenses (in $) in Bangladesh?
Make the answer very short. 6.40e+1. What is the difference between the highest and the lowest Expenses (in $) in Iceland?
Keep it short and to the point. 4.30e+1. What is the difference between the highest and the lowest Expenses (in $) in Lebanon?
Provide a short and direct response. 1.57e+12. What is the difference between the highest and the lowest Expenses (in $) of Maldives?
Your answer should be very brief. 3.01e+09. 